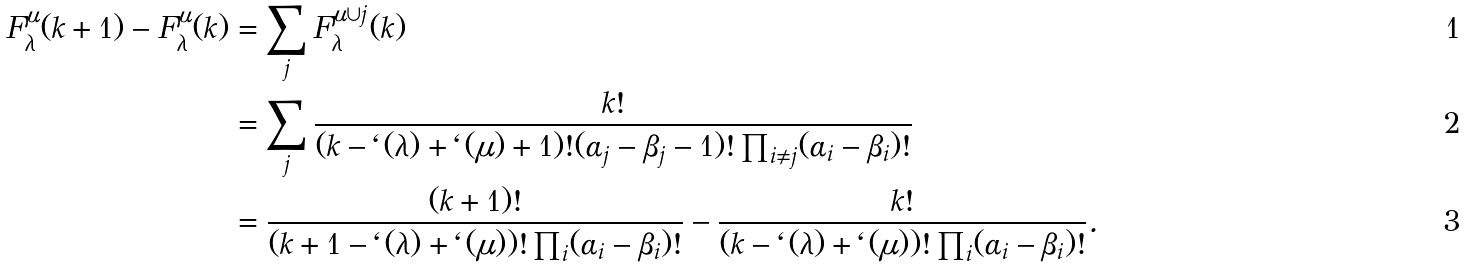Convert formula to latex. <formula><loc_0><loc_0><loc_500><loc_500>F ^ { \mu } _ { \lambda } ( k + 1 ) - F ^ { \mu } _ { \lambda } ( k ) & = \sum _ { j } F ^ { \mu \cup j } _ { \lambda } ( k ) \\ & = \sum _ { j } \frac { k ! } { ( k - \ell ( \lambda ) + \ell ( \mu ) + 1 ) ! ( \alpha _ { j } - \beta _ { j } - 1 ) ! \prod _ { i \neq j } ( \alpha _ { i } - \beta _ { i } ) ! } \\ & = \frac { ( k + 1 ) ! } { ( k + 1 - \ell ( \lambda ) + \ell ( \mu ) ) ! \prod _ { i } ( \alpha _ { i } - \beta _ { i } ) ! } - \frac { k ! } { ( k - \ell ( \lambda ) + \ell ( \mu ) ) ! \prod _ { i } ( \alpha _ { i } - \beta _ { i } ) ! } .</formula> 